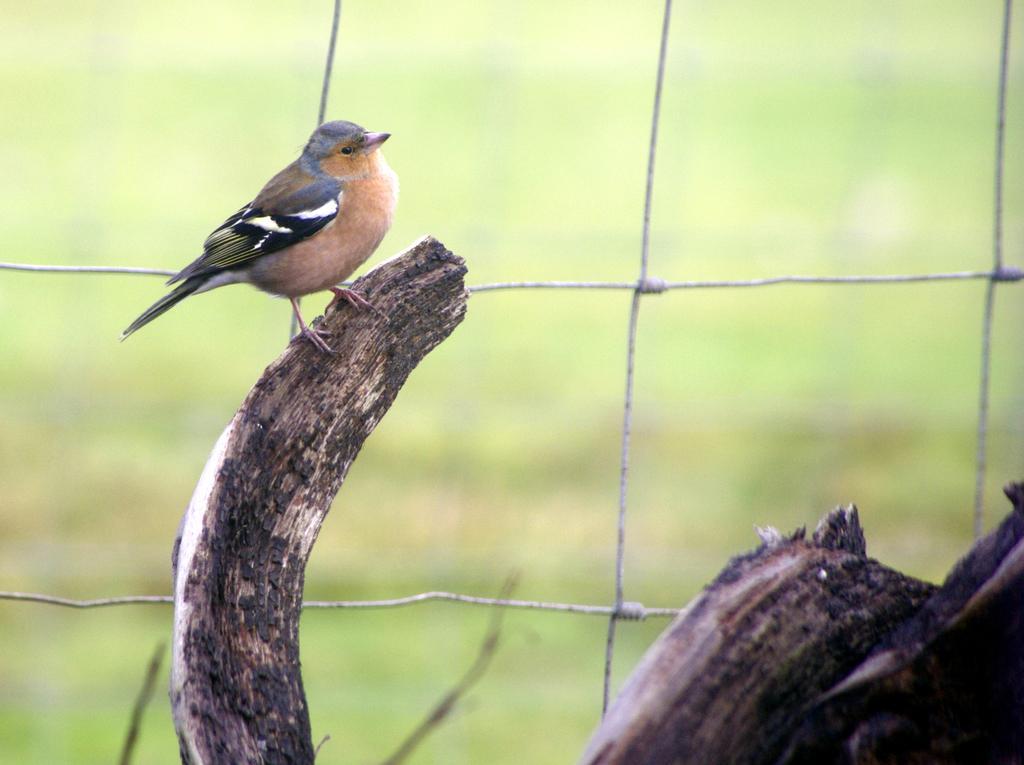Describe this image in one or two sentences. In the image I can see a bird on the stem and behind there is a fencing. 